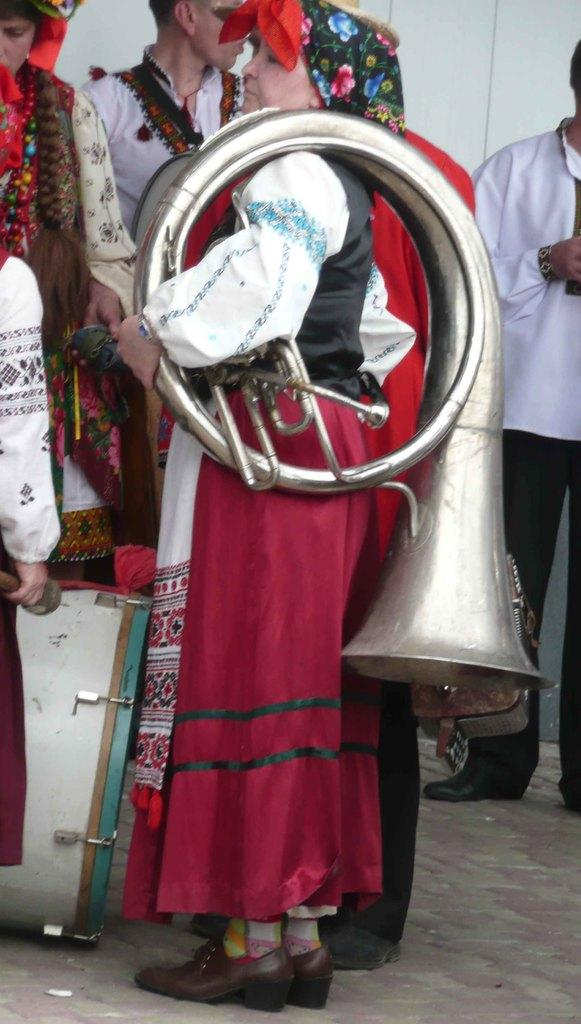What is happening in the image? There are people standing in the image. How are the people dressed? The people are wearing different dress. What is one person doing in the image? One person is holding a musical instrument. Can you identify any musical equipment in the image? Yes, there is a drum visible in the image. What is the background of the image like? There is a white wall in the image. How many cattle can be seen grazing in the image? There are no cattle present in the image. What type of dog is sitting next to the drum in the image? There is no dog present in the image. 